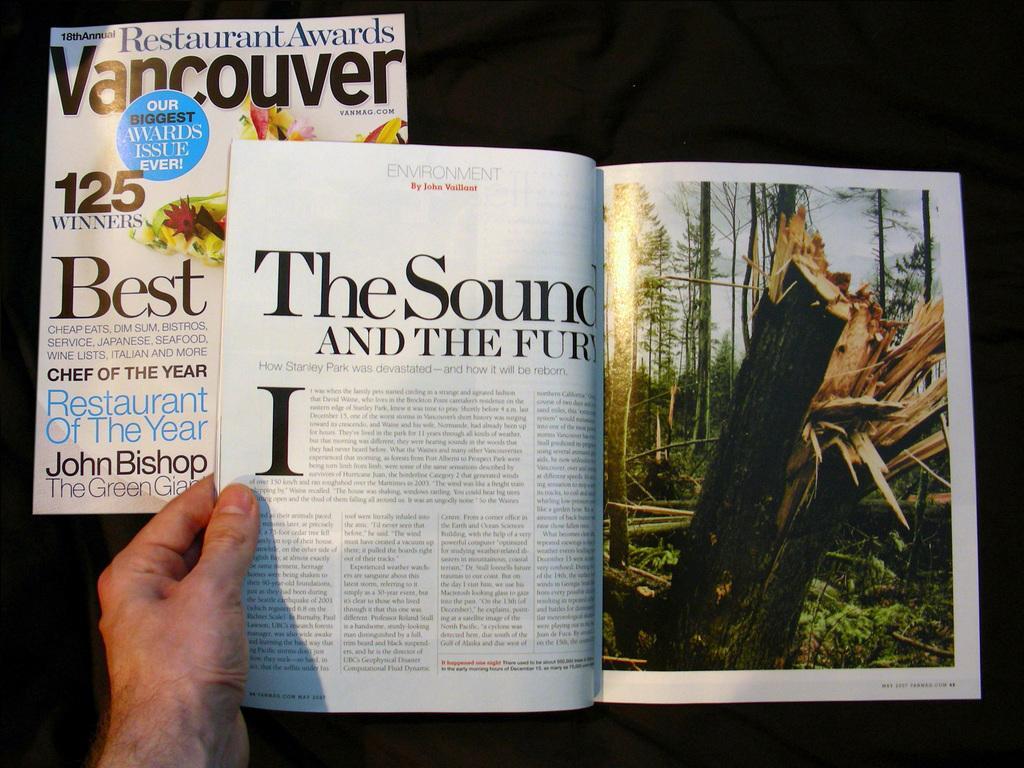How would you summarize this image in a sentence or two? In this image I can see hand of a person is holding a magazine. On the pages of the magazine I can see picture of trees on the right side and on the left side I can see something is written. On the top left side of this image I can see a white colour paper and on it I can see something is written. 